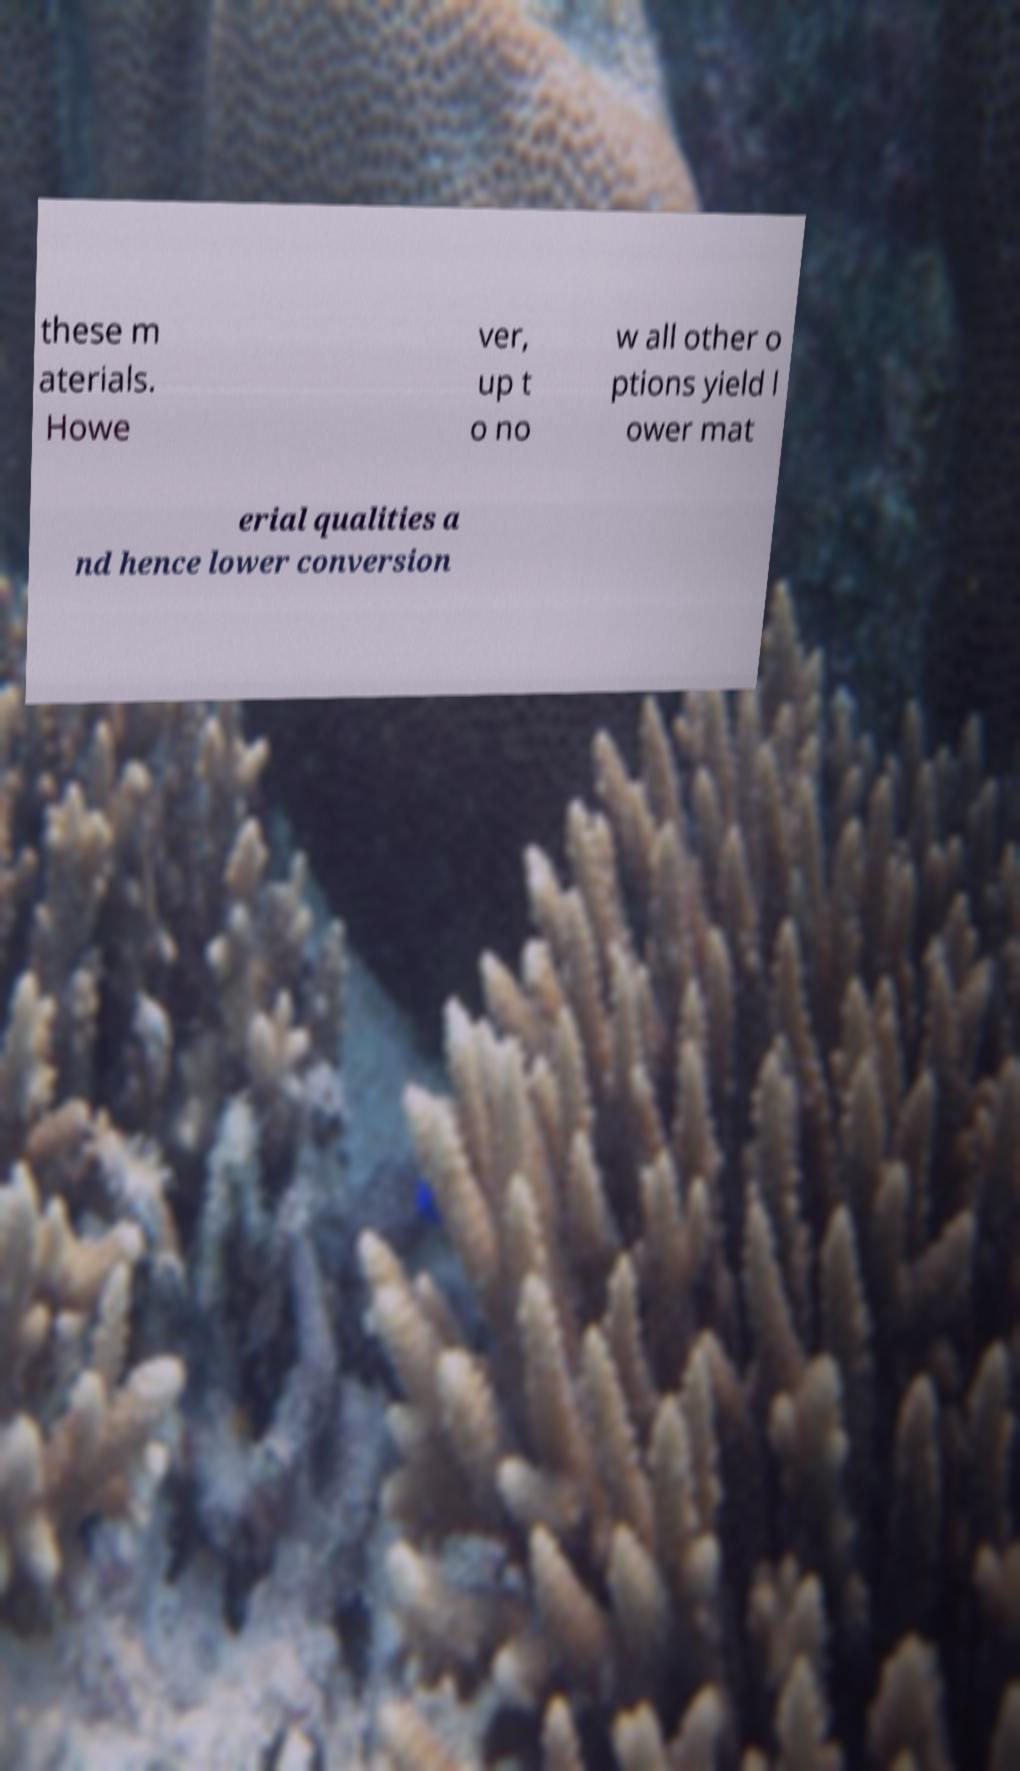Can you read and provide the text displayed in the image?This photo seems to have some interesting text. Can you extract and type it out for me? these m aterials. Howe ver, up t o no w all other o ptions yield l ower mat erial qualities a nd hence lower conversion 